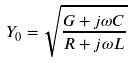Convert formula to latex. <formula><loc_0><loc_0><loc_500><loc_500>Y _ { 0 } = \sqrt { \frac { G + j \omega C } { R + j \omega L } }</formula> 